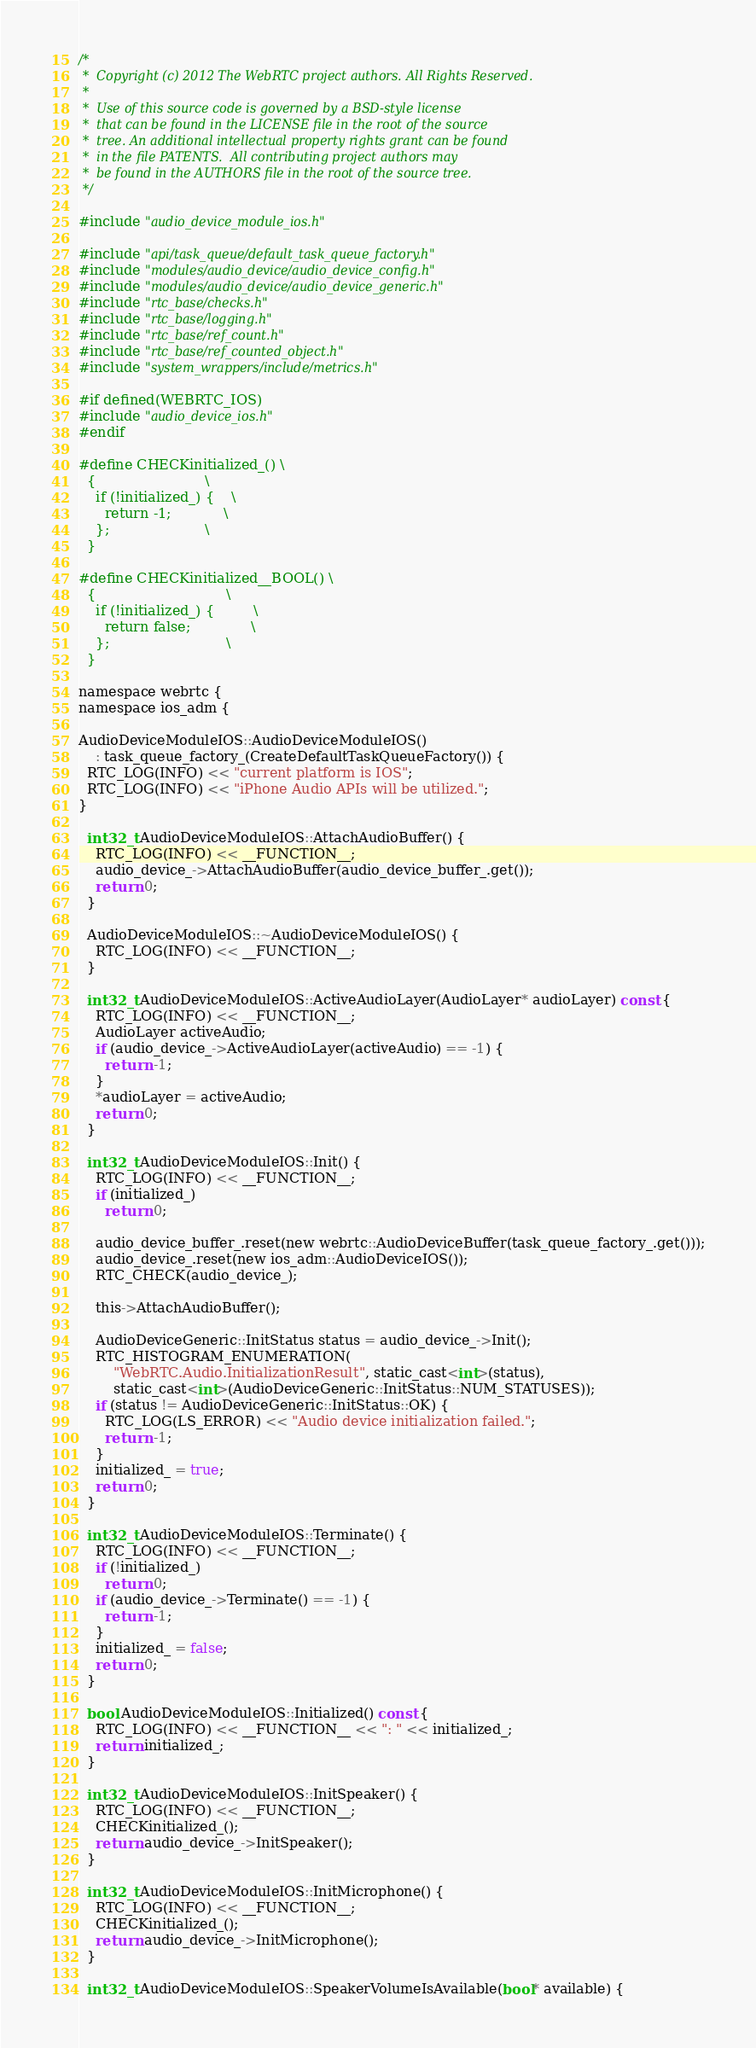Convert code to text. <code><loc_0><loc_0><loc_500><loc_500><_ObjectiveC_>/*
 *  Copyright (c) 2012 The WebRTC project authors. All Rights Reserved.
 *
 *  Use of this source code is governed by a BSD-style license
 *  that can be found in the LICENSE file in the root of the source
 *  tree. An additional intellectual property rights grant can be found
 *  in the file PATENTS.  All contributing project authors may
 *  be found in the AUTHORS file in the root of the source tree.
 */

#include "audio_device_module_ios.h"

#include "api/task_queue/default_task_queue_factory.h"
#include "modules/audio_device/audio_device_config.h"
#include "modules/audio_device/audio_device_generic.h"
#include "rtc_base/checks.h"
#include "rtc_base/logging.h"
#include "rtc_base/ref_count.h"
#include "rtc_base/ref_counted_object.h"
#include "system_wrappers/include/metrics.h"

#if defined(WEBRTC_IOS)
#include "audio_device_ios.h"
#endif

#define CHECKinitialized_() \
  {                         \
    if (!initialized_) {    \
      return -1;            \
    };                      \
  }

#define CHECKinitialized__BOOL() \
  {                              \
    if (!initialized_) {         \
      return false;              \
    };                           \
  }

namespace webrtc {
namespace ios_adm {

AudioDeviceModuleIOS::AudioDeviceModuleIOS()
    : task_queue_factory_(CreateDefaultTaskQueueFactory()) {
  RTC_LOG(INFO) << "current platform is IOS";
  RTC_LOG(INFO) << "iPhone Audio APIs will be utilized.";
}

  int32_t AudioDeviceModuleIOS::AttachAudioBuffer() {
    RTC_LOG(INFO) << __FUNCTION__;
    audio_device_->AttachAudioBuffer(audio_device_buffer_.get());
    return 0;
  }

  AudioDeviceModuleIOS::~AudioDeviceModuleIOS() {
    RTC_LOG(INFO) << __FUNCTION__;
  }

  int32_t AudioDeviceModuleIOS::ActiveAudioLayer(AudioLayer* audioLayer) const {
    RTC_LOG(INFO) << __FUNCTION__;
    AudioLayer activeAudio;
    if (audio_device_->ActiveAudioLayer(activeAudio) == -1) {
      return -1;
    }
    *audioLayer = activeAudio;
    return 0;
  }

  int32_t AudioDeviceModuleIOS::Init() {
    RTC_LOG(INFO) << __FUNCTION__;
    if (initialized_)
      return 0;

    audio_device_buffer_.reset(new webrtc::AudioDeviceBuffer(task_queue_factory_.get()));
    audio_device_.reset(new ios_adm::AudioDeviceIOS());
    RTC_CHECK(audio_device_);

    this->AttachAudioBuffer();

    AudioDeviceGeneric::InitStatus status = audio_device_->Init();
    RTC_HISTOGRAM_ENUMERATION(
        "WebRTC.Audio.InitializationResult", static_cast<int>(status),
        static_cast<int>(AudioDeviceGeneric::InitStatus::NUM_STATUSES));
    if (status != AudioDeviceGeneric::InitStatus::OK) {
      RTC_LOG(LS_ERROR) << "Audio device initialization failed.";
      return -1;
    }
    initialized_ = true;
    return 0;
  }

  int32_t AudioDeviceModuleIOS::Terminate() {
    RTC_LOG(INFO) << __FUNCTION__;
    if (!initialized_)
      return 0;
    if (audio_device_->Terminate() == -1) {
      return -1;
    }
    initialized_ = false;
    return 0;
  }

  bool AudioDeviceModuleIOS::Initialized() const {
    RTC_LOG(INFO) << __FUNCTION__ << ": " << initialized_;
    return initialized_;
  }

  int32_t AudioDeviceModuleIOS::InitSpeaker() {
    RTC_LOG(INFO) << __FUNCTION__;
    CHECKinitialized_();
    return audio_device_->InitSpeaker();
  }

  int32_t AudioDeviceModuleIOS::InitMicrophone() {
    RTC_LOG(INFO) << __FUNCTION__;
    CHECKinitialized_();
    return audio_device_->InitMicrophone();
  }

  int32_t AudioDeviceModuleIOS::SpeakerVolumeIsAvailable(bool* available) {</code> 